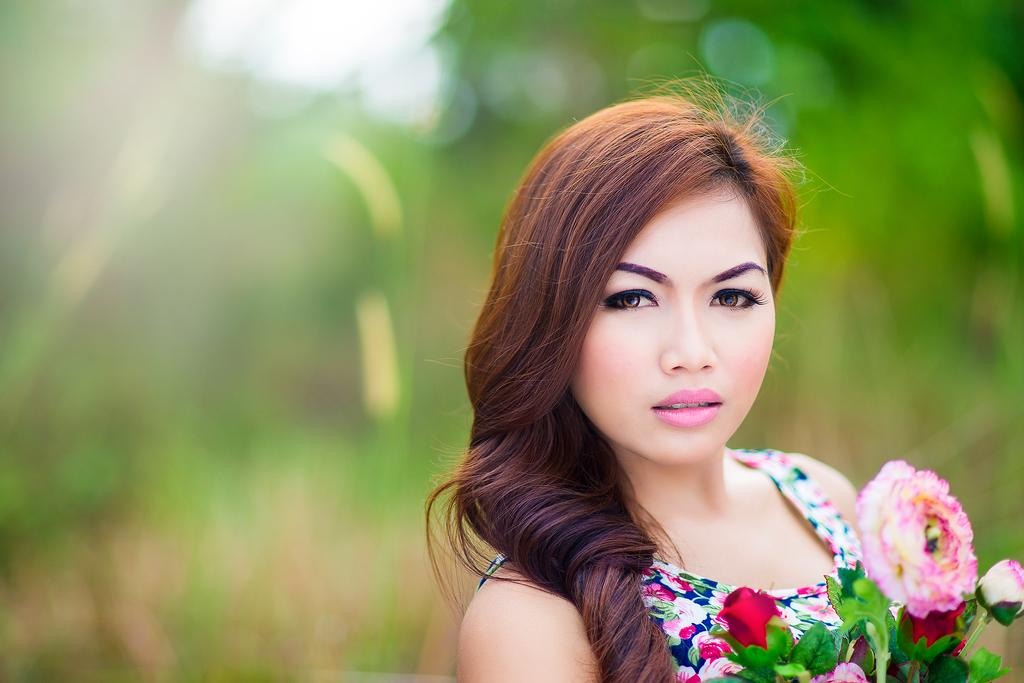Who is the main subject in the image? There is a woman in the image. What is the woman holding in the image? The woman is holding flowers. Can you describe the background of the image? The background of the image is blurred. What type of fight is happening in the background of the image? There is no fight present in the image; the background is blurred. What button is the woman wearing on her shirt in the image? There is no button mentioned or visible on the woman's shirt in the image. 